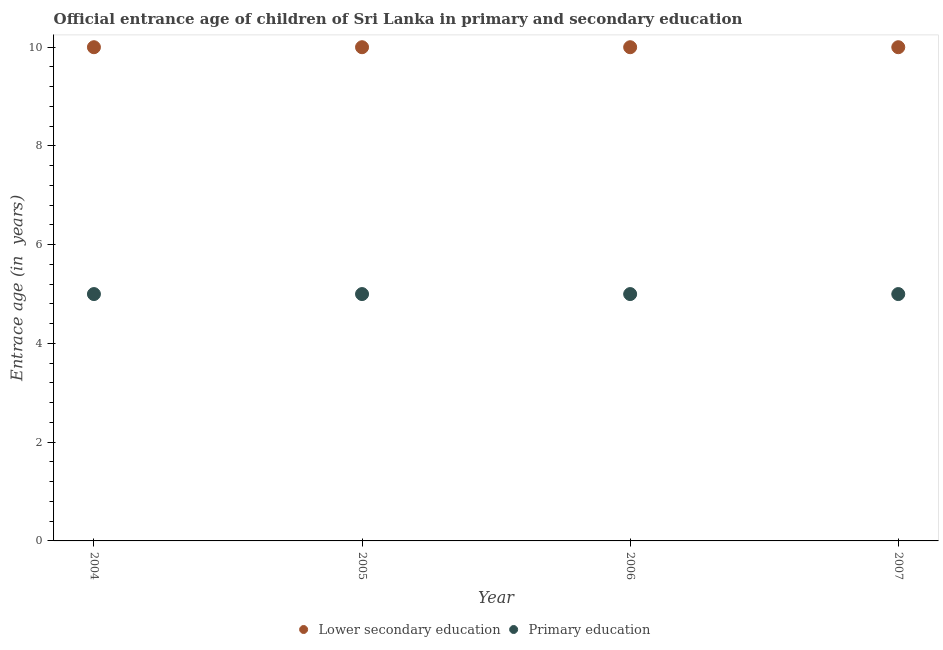What is the entrance age of children in lower secondary education in 2004?
Your response must be concise. 10. Across all years, what is the maximum entrance age of children in lower secondary education?
Offer a very short reply. 10. Across all years, what is the minimum entrance age of children in lower secondary education?
Offer a very short reply. 10. In which year was the entrance age of children in lower secondary education minimum?
Provide a short and direct response. 2004. What is the total entrance age of children in lower secondary education in the graph?
Your response must be concise. 40. What is the difference between the entrance age of children in lower secondary education in 2007 and the entrance age of chiildren in primary education in 2004?
Your answer should be compact. 5. In the year 2005, what is the difference between the entrance age of chiildren in primary education and entrance age of children in lower secondary education?
Offer a very short reply. -5. What is the difference between the highest and the second highest entrance age of children in lower secondary education?
Provide a succinct answer. 0. Is the entrance age of children in lower secondary education strictly greater than the entrance age of chiildren in primary education over the years?
Give a very brief answer. Yes. How many dotlines are there?
Your answer should be very brief. 2. How many years are there in the graph?
Keep it short and to the point. 4. Does the graph contain any zero values?
Make the answer very short. No. How are the legend labels stacked?
Provide a succinct answer. Horizontal. What is the title of the graph?
Provide a succinct answer. Official entrance age of children of Sri Lanka in primary and secondary education. What is the label or title of the Y-axis?
Your answer should be compact. Entrace age (in  years). What is the Entrace age (in  years) in Primary education in 2004?
Keep it short and to the point. 5. What is the Entrace age (in  years) in Lower secondary education in 2005?
Ensure brevity in your answer.  10. What is the Entrace age (in  years) in Primary education in 2007?
Your answer should be compact. 5. Across all years, what is the minimum Entrace age (in  years) of Primary education?
Offer a terse response. 5. What is the total Entrace age (in  years) in Primary education in the graph?
Make the answer very short. 20. What is the difference between the Entrace age (in  years) of Lower secondary education in 2004 and that in 2005?
Your answer should be very brief. 0. What is the difference between the Entrace age (in  years) in Lower secondary education in 2004 and that in 2006?
Your answer should be compact. 0. What is the difference between the Entrace age (in  years) of Lower secondary education in 2005 and that in 2006?
Ensure brevity in your answer.  0. What is the difference between the Entrace age (in  years) of Lower secondary education in 2005 and that in 2007?
Your response must be concise. 0. What is the difference between the Entrace age (in  years) of Primary education in 2006 and that in 2007?
Make the answer very short. 0. What is the difference between the Entrace age (in  years) of Lower secondary education in 2004 and the Entrace age (in  years) of Primary education in 2005?
Provide a succinct answer. 5. What is the difference between the Entrace age (in  years) of Lower secondary education in 2005 and the Entrace age (in  years) of Primary education in 2006?
Your response must be concise. 5. What is the difference between the Entrace age (in  years) of Lower secondary education in 2005 and the Entrace age (in  years) of Primary education in 2007?
Your response must be concise. 5. What is the difference between the Entrace age (in  years) of Lower secondary education in 2006 and the Entrace age (in  years) of Primary education in 2007?
Keep it short and to the point. 5. What is the average Entrace age (in  years) of Lower secondary education per year?
Your answer should be very brief. 10. In the year 2005, what is the difference between the Entrace age (in  years) in Lower secondary education and Entrace age (in  years) in Primary education?
Make the answer very short. 5. In the year 2006, what is the difference between the Entrace age (in  years) of Lower secondary education and Entrace age (in  years) of Primary education?
Give a very brief answer. 5. In the year 2007, what is the difference between the Entrace age (in  years) of Lower secondary education and Entrace age (in  years) of Primary education?
Keep it short and to the point. 5. What is the ratio of the Entrace age (in  years) in Primary education in 2004 to that in 2007?
Your answer should be compact. 1. What is the ratio of the Entrace age (in  years) of Primary education in 2005 to that in 2007?
Your response must be concise. 1. What is the ratio of the Entrace age (in  years) in Lower secondary education in 2006 to that in 2007?
Offer a very short reply. 1. What is the difference between the highest and the second highest Entrace age (in  years) of Lower secondary education?
Keep it short and to the point. 0. What is the difference between the highest and the lowest Entrace age (in  years) of Lower secondary education?
Offer a terse response. 0. What is the difference between the highest and the lowest Entrace age (in  years) in Primary education?
Provide a short and direct response. 0. 